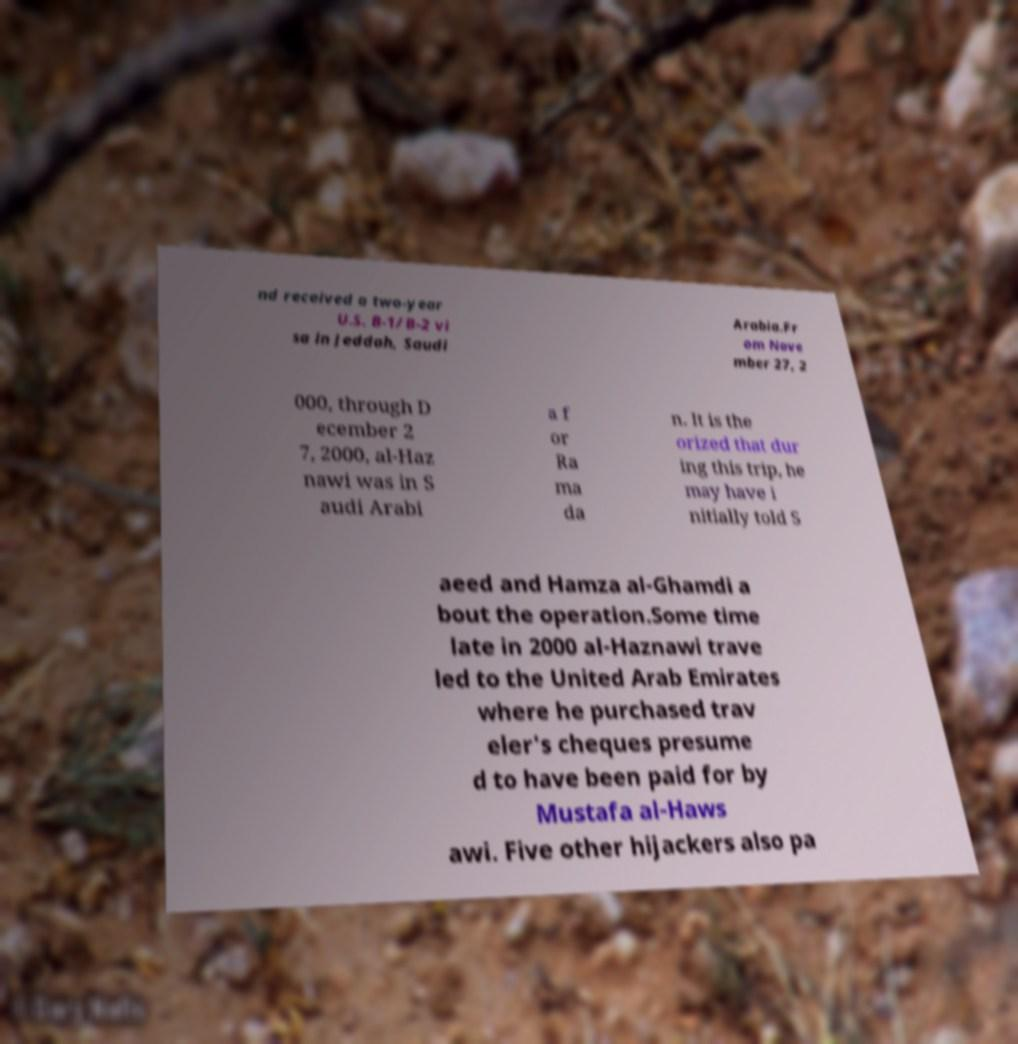There's text embedded in this image that I need extracted. Can you transcribe it verbatim? nd received a two-year U.S. B-1/B-2 vi sa in Jeddah, Saudi Arabia.Fr om Nove mber 27, 2 000, through D ecember 2 7, 2000, al-Haz nawi was in S audi Arabi a f or Ra ma da n. It is the orized that dur ing this trip, he may have i nitially told S aeed and Hamza al-Ghamdi a bout the operation.Some time late in 2000 al-Haznawi trave led to the United Arab Emirates where he purchased trav eler's cheques presume d to have been paid for by Mustafa al-Haws awi. Five other hijackers also pa 